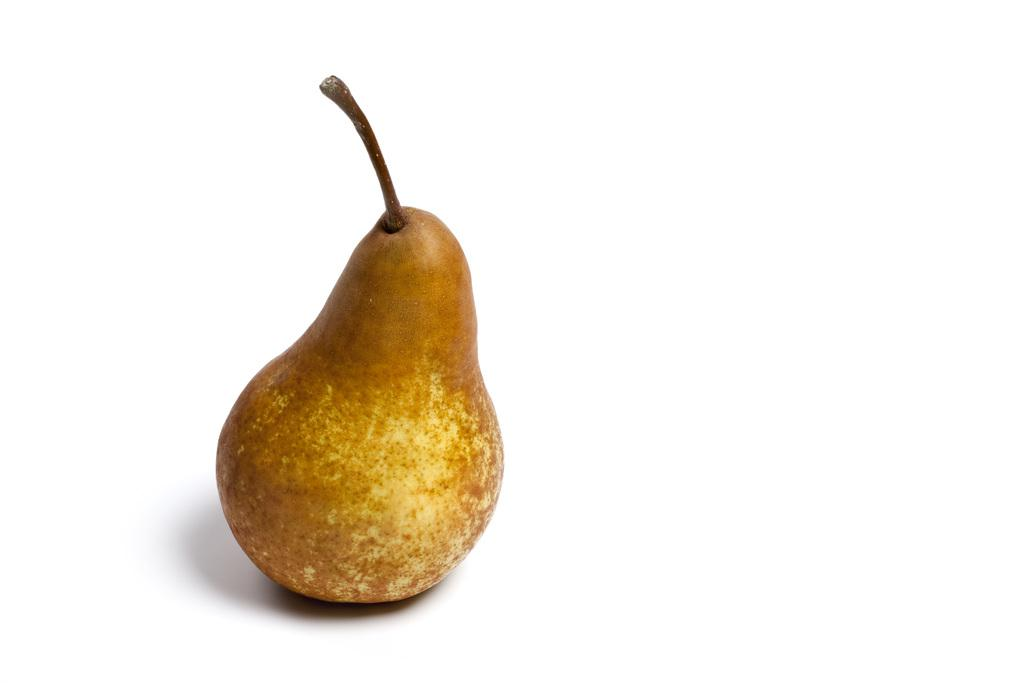What type of fruit is in the picture? There is a pear fruit in the picture. What color is the background of the picture? The background of the picture is white. Can you hear the pear fruit crying in the picture? No, the pear fruit is not capable of making any sounds, including crying, as it is an inanimate object. 